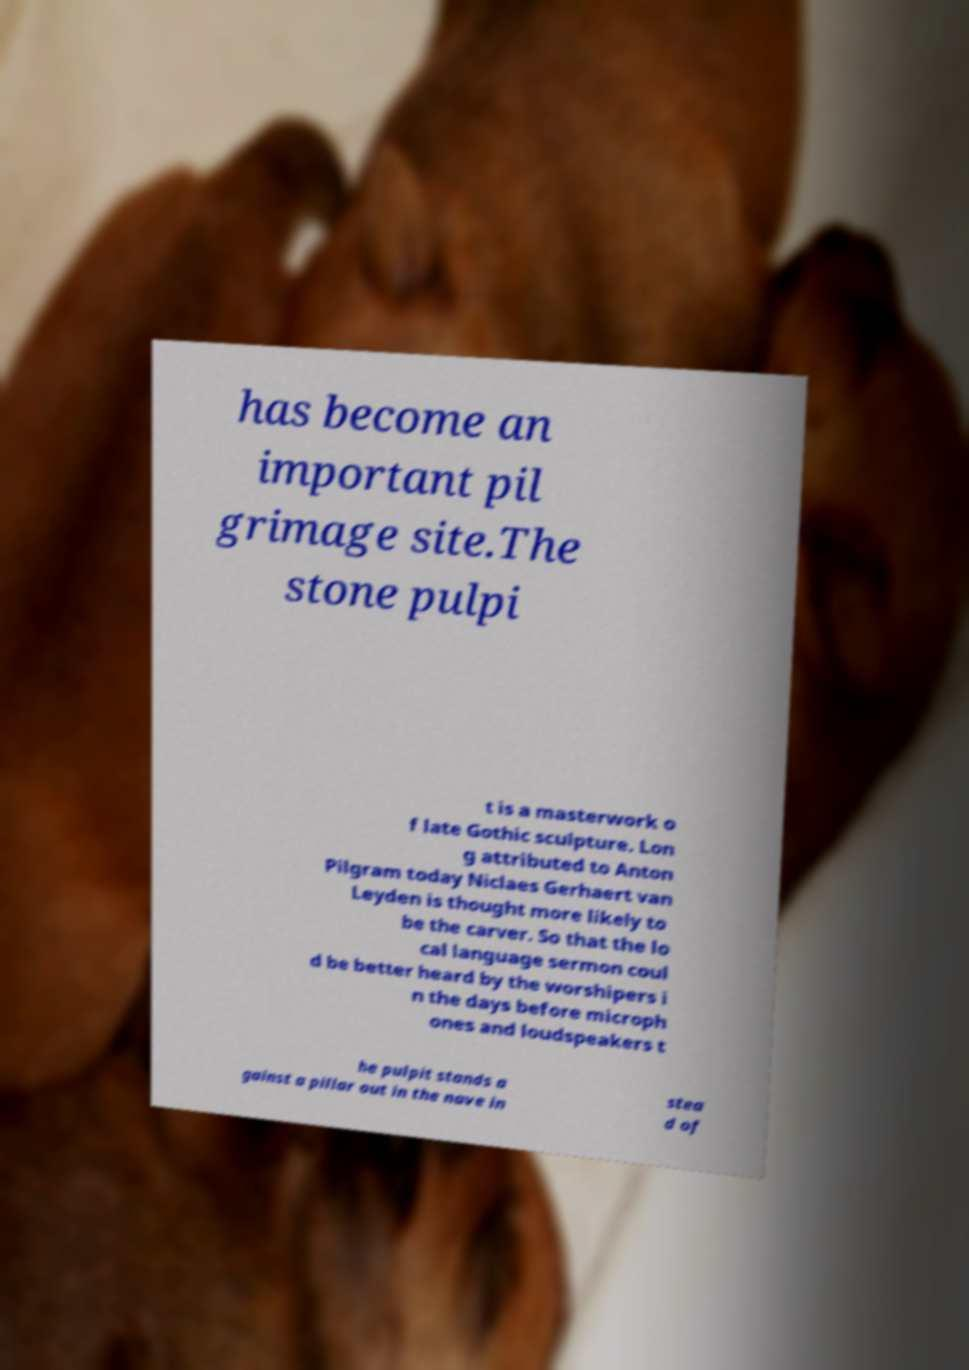Can you accurately transcribe the text from the provided image for me? has become an important pil grimage site.The stone pulpi t is a masterwork o f late Gothic sculpture. Lon g attributed to Anton Pilgram today Niclaes Gerhaert van Leyden is thought more likely to be the carver. So that the lo cal language sermon coul d be better heard by the worshipers i n the days before microph ones and loudspeakers t he pulpit stands a gainst a pillar out in the nave in stea d of 